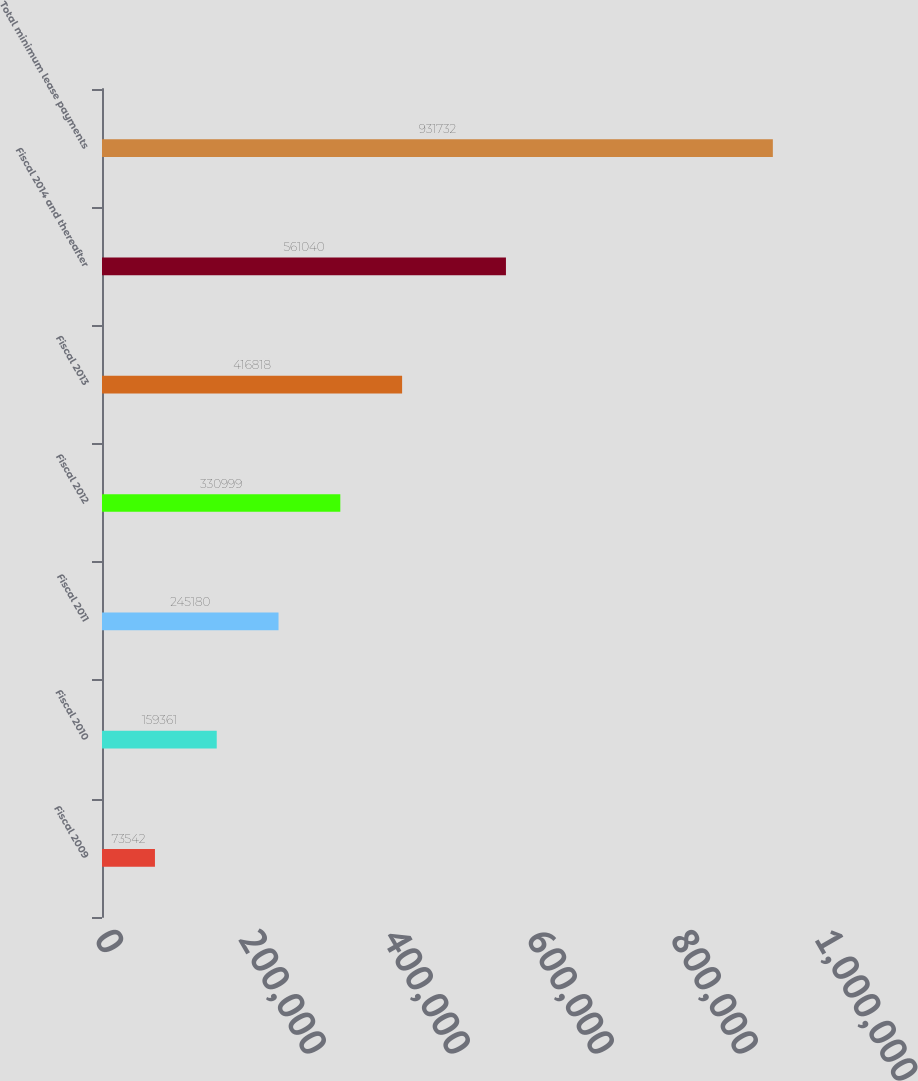<chart> <loc_0><loc_0><loc_500><loc_500><bar_chart><fcel>Fiscal 2009<fcel>Fiscal 2010<fcel>Fiscal 2011<fcel>Fiscal 2012<fcel>Fiscal 2013<fcel>Fiscal 2014 and thereafter<fcel>Total minimum lease payments<nl><fcel>73542<fcel>159361<fcel>245180<fcel>330999<fcel>416818<fcel>561040<fcel>931732<nl></chart> 